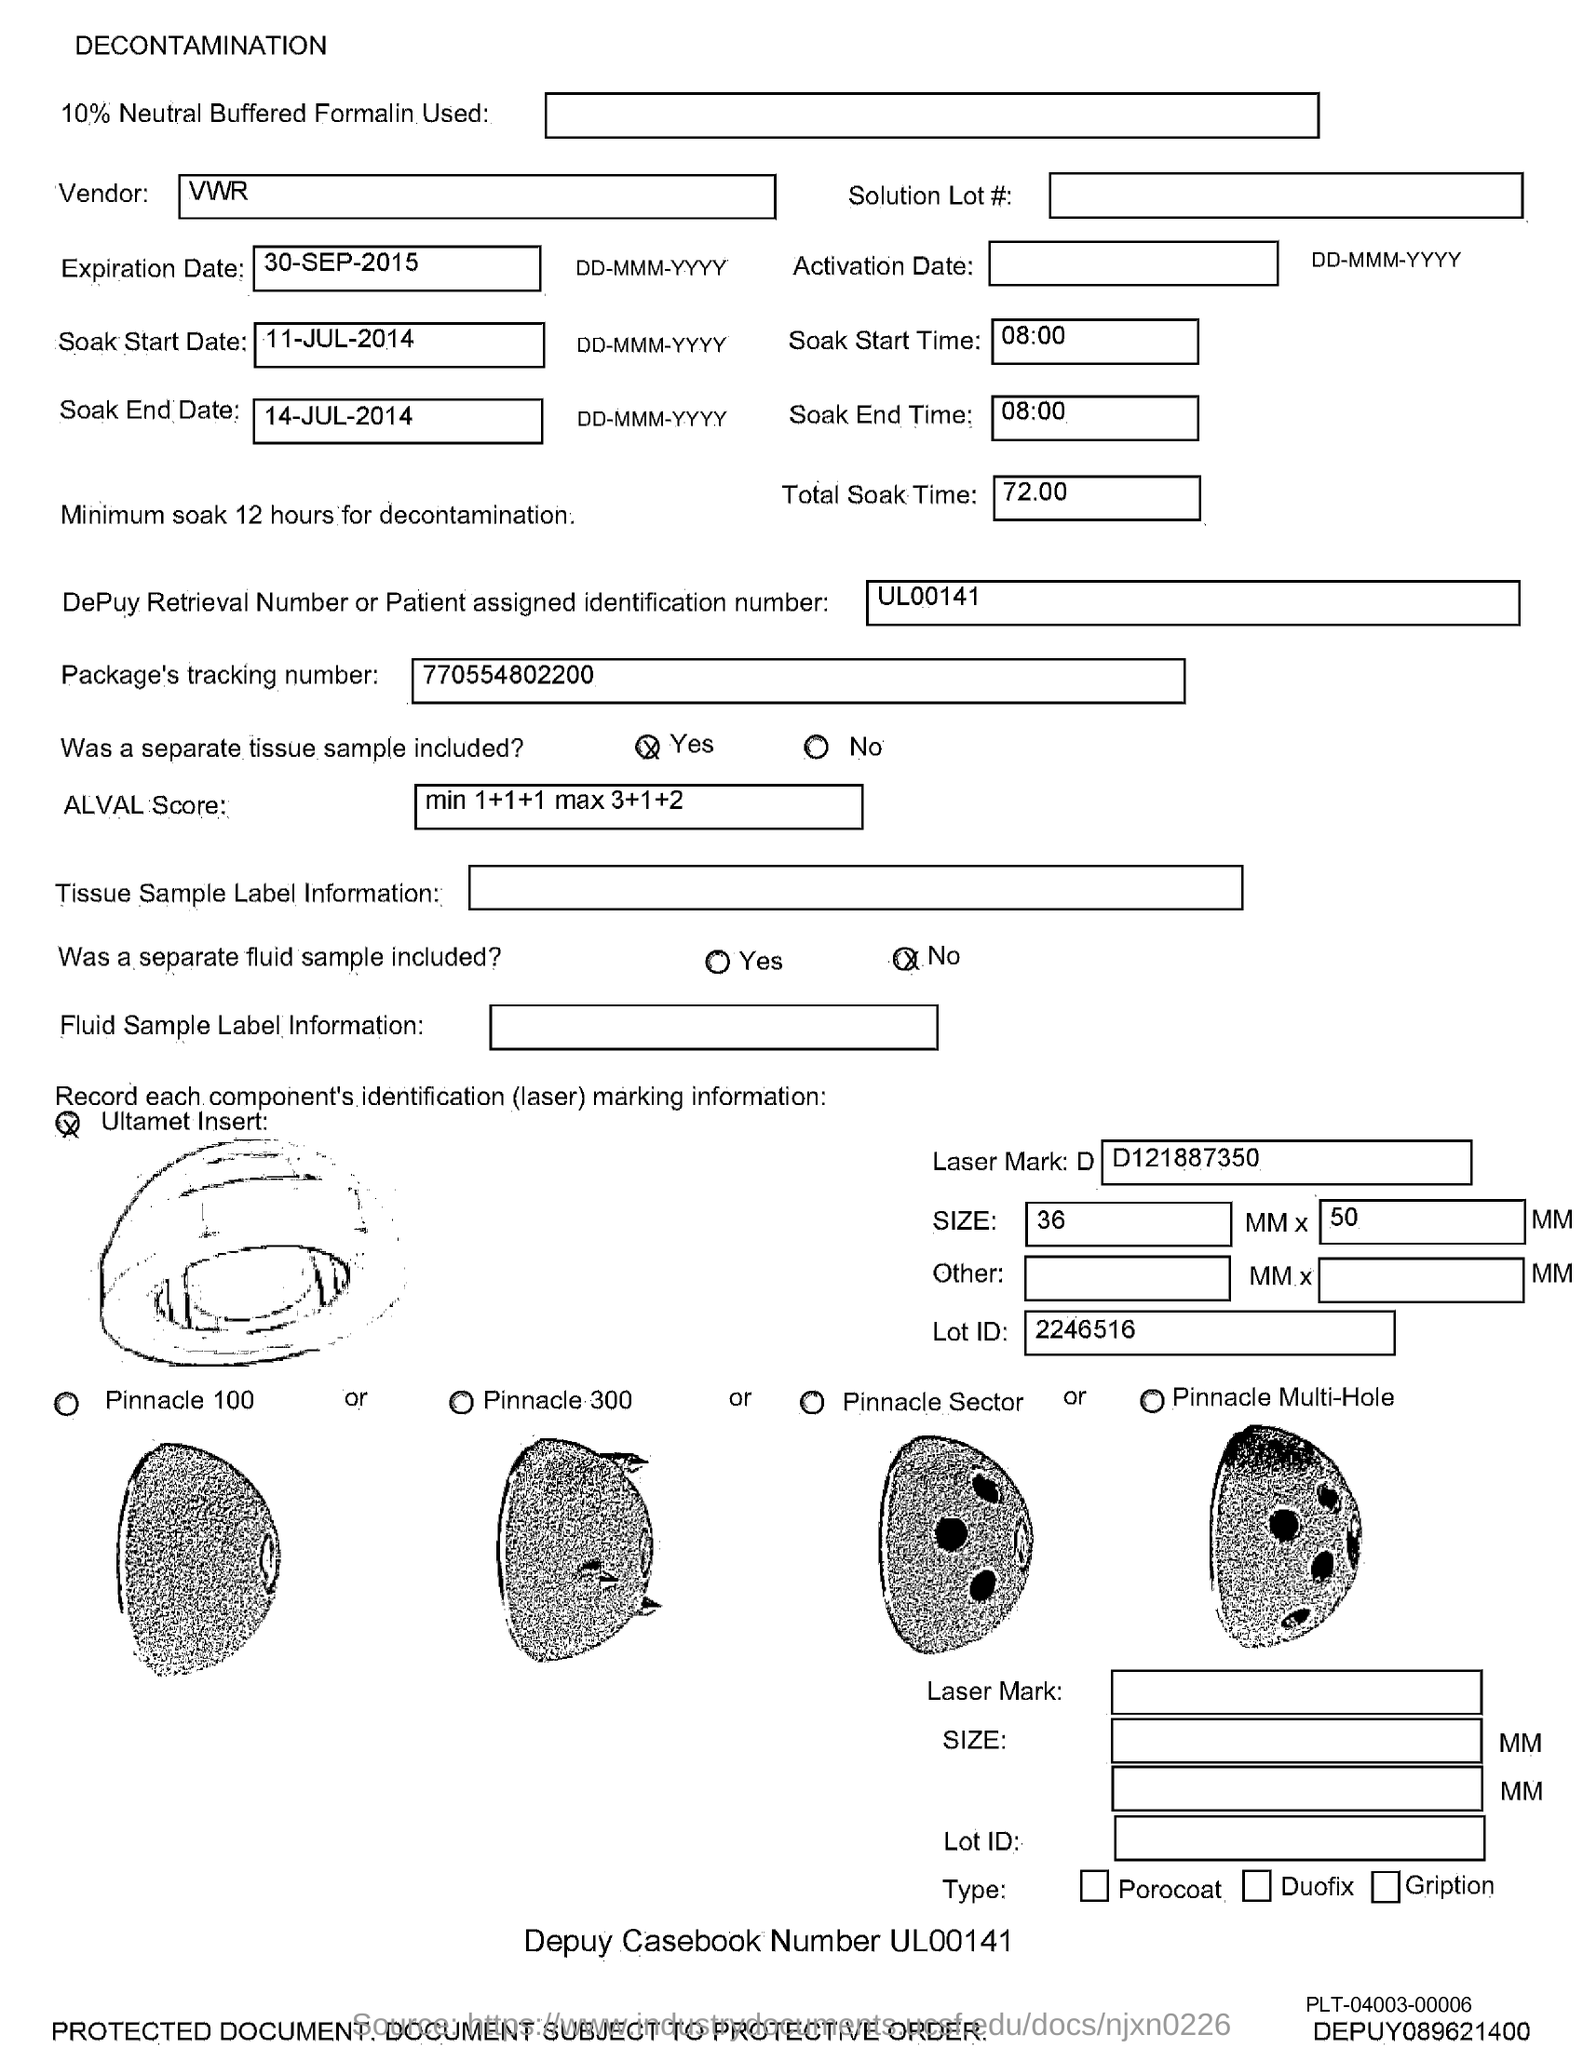What is the expiration date ?
Your answer should be very brief. 30-sep-2015. What is the soak start date?
Your response must be concise. 11-Jul-2014. What is the soak end date?
Your answer should be compact. 14-Jul-2014. What is the soak start time ?
Your answer should be very brief. 08:00. What is soak end time ?
Provide a succinct answer. 08:00. What is the total soak time ?
Your answer should be compact. 72.00. What is depuy retrieval number or patient assigned identification number ?
Make the answer very short. Ul00141. What is package's tracking number ?
Offer a terse response. 770554802200. What is the lot id?
Make the answer very short. 2246516. What is the depuy casebook number ?
Provide a succinct answer. Ul00141. 